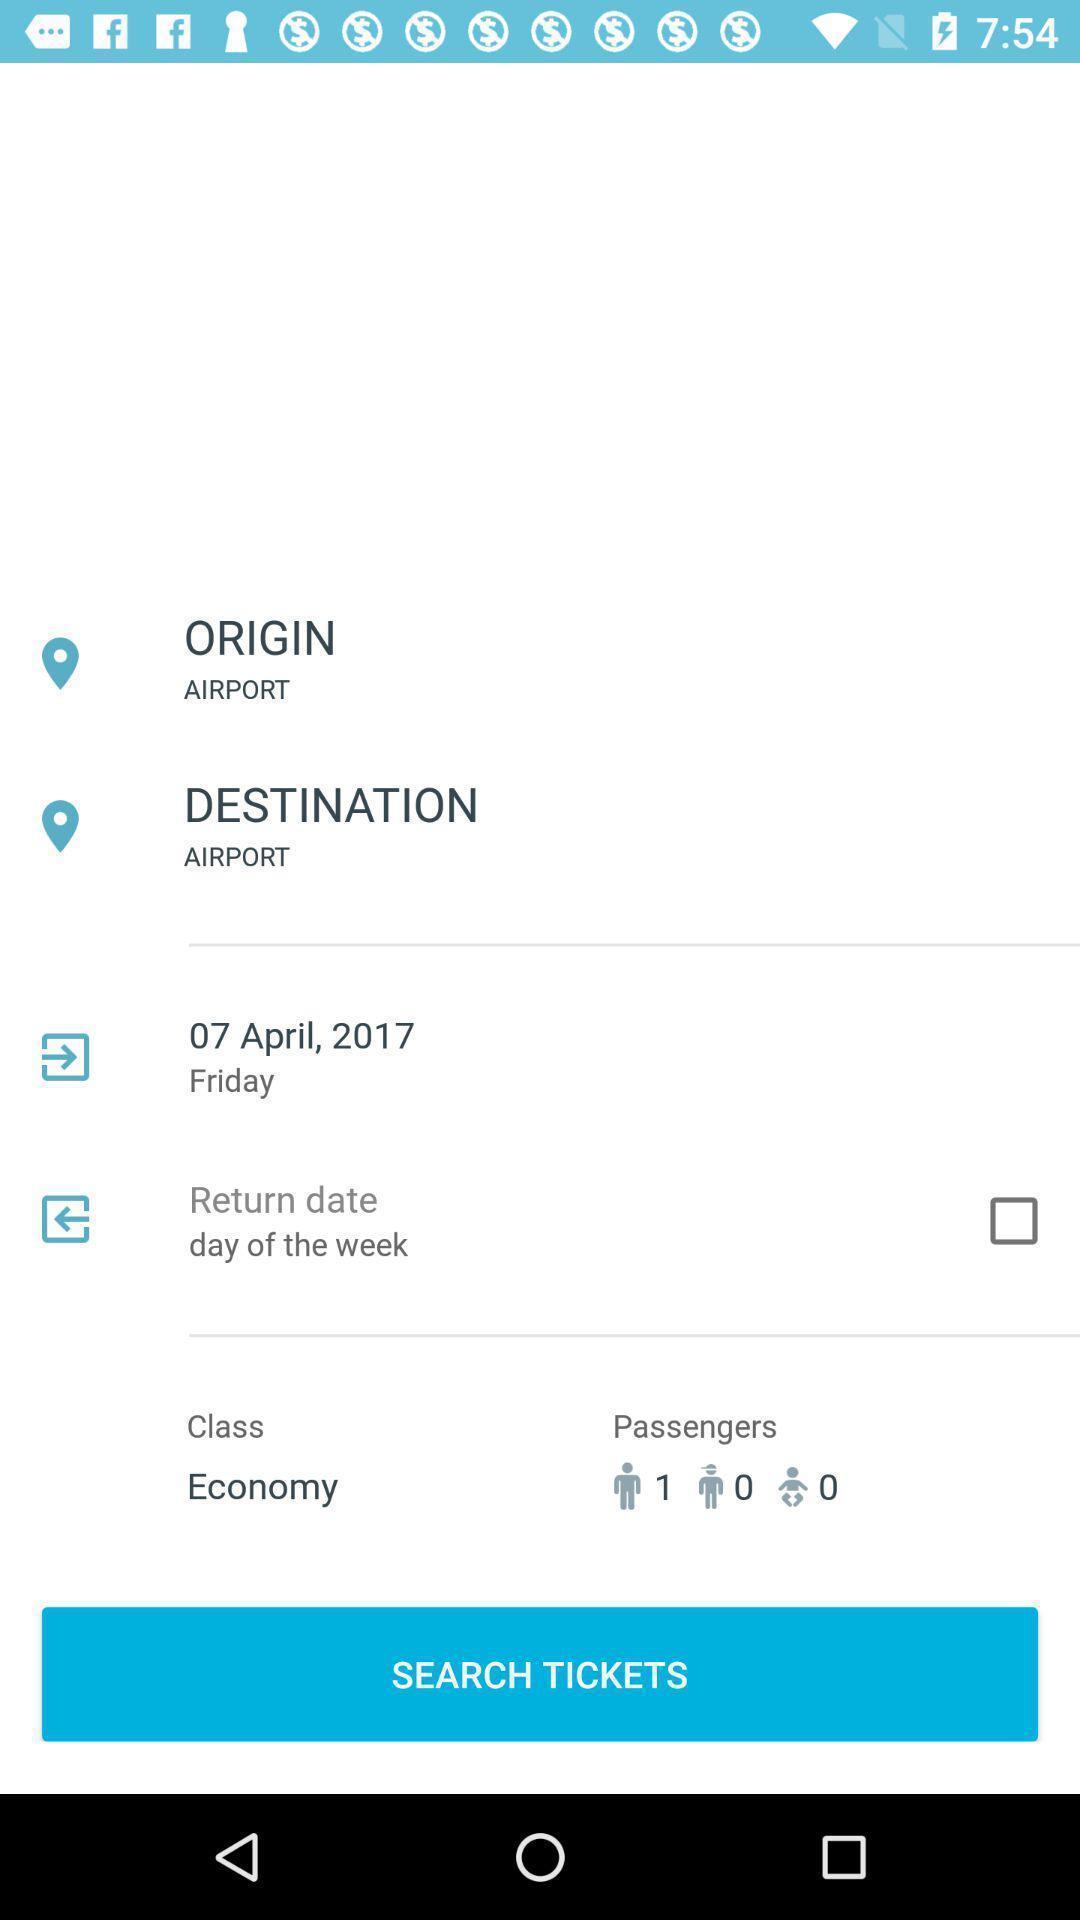What can you discern from this picture? User page for a flight booking app. 